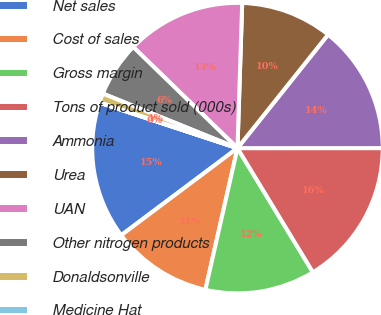Convert chart to OTSL. <chart><loc_0><loc_0><loc_500><loc_500><pie_chart><fcel>Net sales<fcel>Cost of sales<fcel>Gross margin<fcel>Tons of product sold (000s)<fcel>Ammonia<fcel>Urea<fcel>UAN<fcel>Other nitrogen products<fcel>Donaldsonville<fcel>Medicine Hat<nl><fcel>15.3%<fcel>11.22%<fcel>12.24%<fcel>16.31%<fcel>14.28%<fcel>10.2%<fcel>13.26%<fcel>6.13%<fcel>1.04%<fcel>0.02%<nl></chart> 